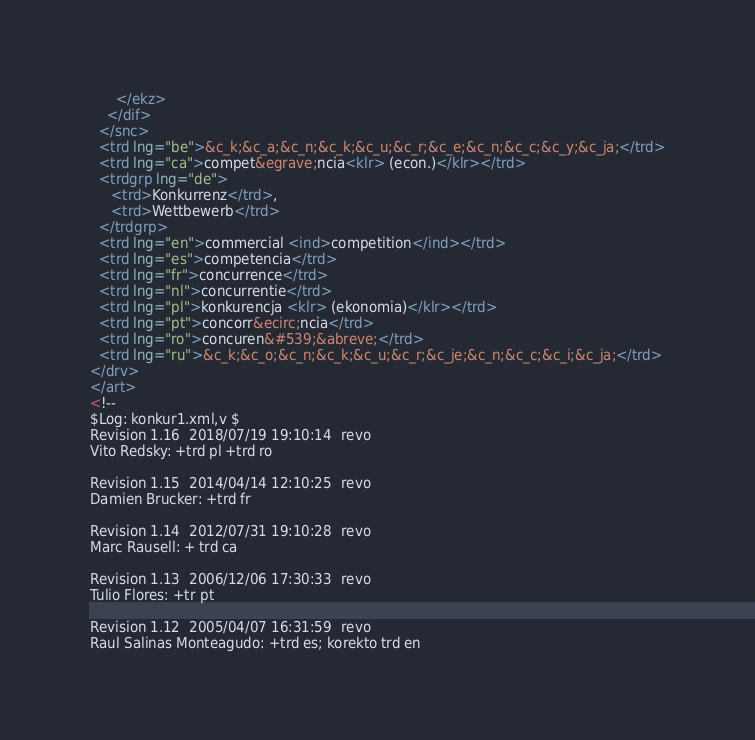<code> <loc_0><loc_0><loc_500><loc_500><_XML_>      </ekz>
    </dif>
  </snc>
  <trd lng="be">&c_k;&c_a;&c_n;&c_k;&c_u;&c_r;&c_e;&c_n;&c_c;&c_y;&c_ja;</trd>
  <trd lng="ca">compet&egrave;ncia<klr> (econ.)</klr></trd>
  <trdgrp lng="de">
     <trd>Konkurrenz</trd>,
     <trd>Wettbewerb</trd>
  </trdgrp>
  <trd lng="en">commercial <ind>competition</ind></trd>
  <trd lng="es">competencia</trd>
  <trd lng="fr">concurrence</trd>
  <trd lng="nl">concurrentie</trd>
  <trd lng="pl">konkurencja <klr> (ekonomia)</klr></trd>
  <trd lng="pt">concorr&ecirc;ncia</trd>
  <trd lng="ro">concuren&#539;&abreve;</trd>
  <trd lng="ru">&c_k;&c_o;&c_n;&c_k;&c_u;&c_r;&c_je;&c_n;&c_c;&c_i;&c_ja;</trd>
</drv>
</art>
<!--
$Log: konkur1.xml,v $
Revision 1.16  2018/07/19 19:10:14  revo
Vito Redsky: +trd pl +trd ro

Revision 1.15  2014/04/14 12:10:25  revo
Damien Brucker: +trd fr

Revision 1.14  2012/07/31 19:10:28  revo
Marc Rausell: + trd ca

Revision 1.13  2006/12/06 17:30:33  revo
Tulio Flores: +tr pt

Revision 1.12  2005/04/07 16:31:59  revo
Raul Salinas Monteagudo: +trd es; korekto trd en
</code> 